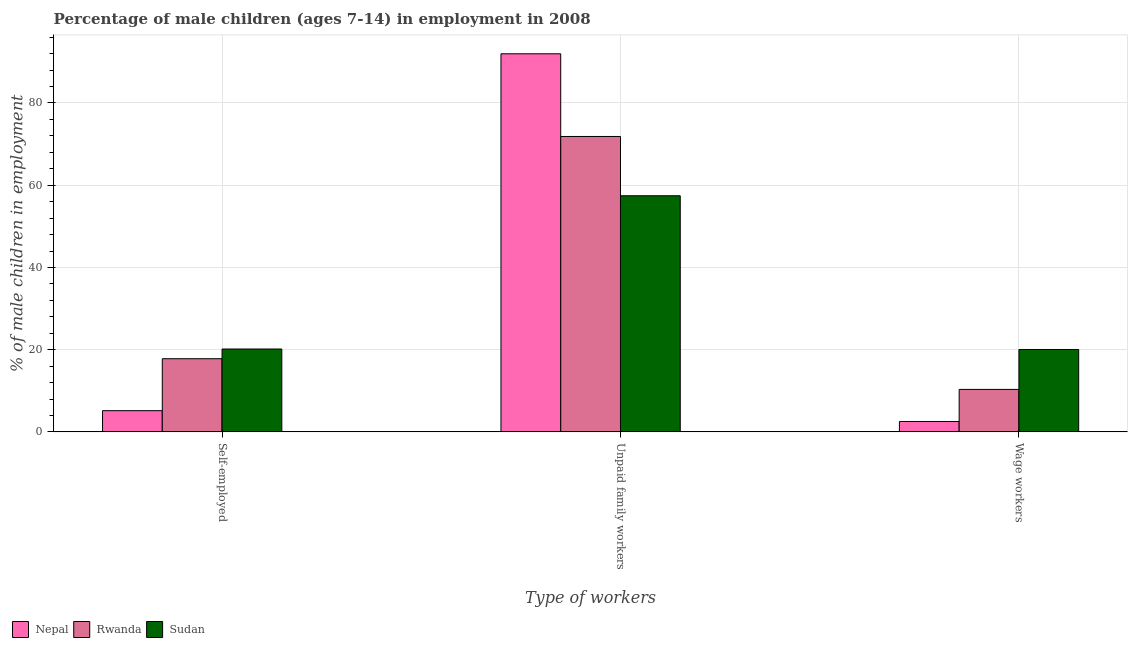How many different coloured bars are there?
Provide a short and direct response. 3. How many groups of bars are there?
Ensure brevity in your answer.  3. Are the number of bars on each tick of the X-axis equal?
Offer a very short reply. Yes. What is the label of the 1st group of bars from the left?
Offer a very short reply. Self-employed. What is the percentage of self employed children in Nepal?
Give a very brief answer. 5.17. Across all countries, what is the maximum percentage of self employed children?
Your response must be concise. 20.17. Across all countries, what is the minimum percentage of self employed children?
Ensure brevity in your answer.  5.17. In which country was the percentage of children employed as unpaid family workers maximum?
Your answer should be very brief. Nepal. In which country was the percentage of children employed as wage workers minimum?
Offer a terse response. Nepal. What is the total percentage of children employed as unpaid family workers in the graph?
Provide a short and direct response. 221.27. What is the difference between the percentage of self employed children in Sudan and that in Nepal?
Offer a terse response. 15. What is the difference between the percentage of children employed as wage workers in Nepal and the percentage of self employed children in Sudan?
Keep it short and to the point. -17.63. What is the average percentage of self employed children per country?
Your response must be concise. 14.38. What is the difference between the percentage of self employed children and percentage of children employed as wage workers in Rwanda?
Your answer should be compact. 7.47. What is the ratio of the percentage of children employed as unpaid family workers in Rwanda to that in Sudan?
Make the answer very short. 1.25. Is the percentage of children employed as wage workers in Rwanda less than that in Nepal?
Keep it short and to the point. No. Is the difference between the percentage of children employed as unpaid family workers in Nepal and Sudan greater than the difference between the percentage of self employed children in Nepal and Sudan?
Keep it short and to the point. Yes. What is the difference between the highest and the second highest percentage of children employed as wage workers?
Offer a terse response. 9.71. What is the difference between the highest and the lowest percentage of children employed as unpaid family workers?
Ensure brevity in your answer.  34.53. In how many countries, is the percentage of self employed children greater than the average percentage of self employed children taken over all countries?
Give a very brief answer. 2. Is the sum of the percentage of self employed children in Rwanda and Nepal greater than the maximum percentage of children employed as wage workers across all countries?
Give a very brief answer. Yes. What does the 2nd bar from the left in Wage workers represents?
Give a very brief answer. Rwanda. What does the 3rd bar from the right in Unpaid family workers represents?
Make the answer very short. Nepal. How many bars are there?
Your response must be concise. 9. How many countries are there in the graph?
Keep it short and to the point. 3. Does the graph contain grids?
Offer a terse response. Yes. Where does the legend appear in the graph?
Your response must be concise. Bottom left. How many legend labels are there?
Keep it short and to the point. 3. What is the title of the graph?
Your answer should be compact. Percentage of male children (ages 7-14) in employment in 2008. Does "Small states" appear as one of the legend labels in the graph?
Provide a succinct answer. No. What is the label or title of the X-axis?
Give a very brief answer. Type of workers. What is the label or title of the Y-axis?
Your answer should be very brief. % of male children in employment. What is the % of male children in employment of Nepal in Self-employed?
Your response must be concise. 5.17. What is the % of male children in employment of Rwanda in Self-employed?
Your answer should be very brief. 17.81. What is the % of male children in employment in Sudan in Self-employed?
Offer a terse response. 20.17. What is the % of male children in employment in Nepal in Unpaid family workers?
Offer a terse response. 91.97. What is the % of male children in employment in Rwanda in Unpaid family workers?
Make the answer very short. 71.86. What is the % of male children in employment in Sudan in Unpaid family workers?
Offer a very short reply. 57.44. What is the % of male children in employment in Nepal in Wage workers?
Make the answer very short. 2.54. What is the % of male children in employment of Rwanda in Wage workers?
Your answer should be compact. 10.34. What is the % of male children in employment in Sudan in Wage workers?
Provide a succinct answer. 20.05. Across all Type of workers, what is the maximum % of male children in employment of Nepal?
Ensure brevity in your answer.  91.97. Across all Type of workers, what is the maximum % of male children in employment in Rwanda?
Offer a very short reply. 71.86. Across all Type of workers, what is the maximum % of male children in employment in Sudan?
Your response must be concise. 57.44. Across all Type of workers, what is the minimum % of male children in employment in Nepal?
Give a very brief answer. 2.54. Across all Type of workers, what is the minimum % of male children in employment in Rwanda?
Ensure brevity in your answer.  10.34. Across all Type of workers, what is the minimum % of male children in employment in Sudan?
Your response must be concise. 20.05. What is the total % of male children in employment of Nepal in the graph?
Provide a succinct answer. 99.68. What is the total % of male children in employment of Rwanda in the graph?
Provide a succinct answer. 100.01. What is the total % of male children in employment of Sudan in the graph?
Give a very brief answer. 97.66. What is the difference between the % of male children in employment of Nepal in Self-employed and that in Unpaid family workers?
Offer a terse response. -86.8. What is the difference between the % of male children in employment in Rwanda in Self-employed and that in Unpaid family workers?
Give a very brief answer. -54.05. What is the difference between the % of male children in employment in Sudan in Self-employed and that in Unpaid family workers?
Your response must be concise. -37.27. What is the difference between the % of male children in employment in Nepal in Self-employed and that in Wage workers?
Provide a short and direct response. 2.63. What is the difference between the % of male children in employment of Rwanda in Self-employed and that in Wage workers?
Make the answer very short. 7.47. What is the difference between the % of male children in employment of Sudan in Self-employed and that in Wage workers?
Your response must be concise. 0.12. What is the difference between the % of male children in employment in Nepal in Unpaid family workers and that in Wage workers?
Offer a terse response. 89.43. What is the difference between the % of male children in employment in Rwanda in Unpaid family workers and that in Wage workers?
Your answer should be compact. 61.52. What is the difference between the % of male children in employment in Sudan in Unpaid family workers and that in Wage workers?
Offer a terse response. 37.39. What is the difference between the % of male children in employment in Nepal in Self-employed and the % of male children in employment in Rwanda in Unpaid family workers?
Offer a terse response. -66.69. What is the difference between the % of male children in employment of Nepal in Self-employed and the % of male children in employment of Sudan in Unpaid family workers?
Make the answer very short. -52.27. What is the difference between the % of male children in employment in Rwanda in Self-employed and the % of male children in employment in Sudan in Unpaid family workers?
Your answer should be compact. -39.63. What is the difference between the % of male children in employment in Nepal in Self-employed and the % of male children in employment in Rwanda in Wage workers?
Offer a very short reply. -5.17. What is the difference between the % of male children in employment in Nepal in Self-employed and the % of male children in employment in Sudan in Wage workers?
Your answer should be compact. -14.88. What is the difference between the % of male children in employment of Rwanda in Self-employed and the % of male children in employment of Sudan in Wage workers?
Provide a succinct answer. -2.24. What is the difference between the % of male children in employment in Nepal in Unpaid family workers and the % of male children in employment in Rwanda in Wage workers?
Provide a succinct answer. 81.63. What is the difference between the % of male children in employment in Nepal in Unpaid family workers and the % of male children in employment in Sudan in Wage workers?
Offer a terse response. 71.92. What is the difference between the % of male children in employment of Rwanda in Unpaid family workers and the % of male children in employment of Sudan in Wage workers?
Keep it short and to the point. 51.81. What is the average % of male children in employment of Nepal per Type of workers?
Provide a short and direct response. 33.23. What is the average % of male children in employment of Rwanda per Type of workers?
Your response must be concise. 33.34. What is the average % of male children in employment of Sudan per Type of workers?
Your answer should be compact. 32.55. What is the difference between the % of male children in employment in Nepal and % of male children in employment in Rwanda in Self-employed?
Ensure brevity in your answer.  -12.64. What is the difference between the % of male children in employment of Nepal and % of male children in employment of Sudan in Self-employed?
Ensure brevity in your answer.  -15. What is the difference between the % of male children in employment in Rwanda and % of male children in employment in Sudan in Self-employed?
Ensure brevity in your answer.  -2.36. What is the difference between the % of male children in employment of Nepal and % of male children in employment of Rwanda in Unpaid family workers?
Provide a succinct answer. 20.11. What is the difference between the % of male children in employment in Nepal and % of male children in employment in Sudan in Unpaid family workers?
Keep it short and to the point. 34.53. What is the difference between the % of male children in employment of Rwanda and % of male children in employment of Sudan in Unpaid family workers?
Your response must be concise. 14.42. What is the difference between the % of male children in employment of Nepal and % of male children in employment of Sudan in Wage workers?
Your response must be concise. -17.51. What is the difference between the % of male children in employment in Rwanda and % of male children in employment in Sudan in Wage workers?
Ensure brevity in your answer.  -9.71. What is the ratio of the % of male children in employment in Nepal in Self-employed to that in Unpaid family workers?
Provide a short and direct response. 0.06. What is the ratio of the % of male children in employment of Rwanda in Self-employed to that in Unpaid family workers?
Ensure brevity in your answer.  0.25. What is the ratio of the % of male children in employment in Sudan in Self-employed to that in Unpaid family workers?
Make the answer very short. 0.35. What is the ratio of the % of male children in employment of Nepal in Self-employed to that in Wage workers?
Keep it short and to the point. 2.04. What is the ratio of the % of male children in employment in Rwanda in Self-employed to that in Wage workers?
Provide a short and direct response. 1.72. What is the ratio of the % of male children in employment of Sudan in Self-employed to that in Wage workers?
Ensure brevity in your answer.  1.01. What is the ratio of the % of male children in employment in Nepal in Unpaid family workers to that in Wage workers?
Offer a very short reply. 36.21. What is the ratio of the % of male children in employment of Rwanda in Unpaid family workers to that in Wage workers?
Keep it short and to the point. 6.95. What is the ratio of the % of male children in employment in Sudan in Unpaid family workers to that in Wage workers?
Your response must be concise. 2.86. What is the difference between the highest and the second highest % of male children in employment in Nepal?
Provide a succinct answer. 86.8. What is the difference between the highest and the second highest % of male children in employment of Rwanda?
Keep it short and to the point. 54.05. What is the difference between the highest and the second highest % of male children in employment of Sudan?
Your answer should be very brief. 37.27. What is the difference between the highest and the lowest % of male children in employment of Nepal?
Your response must be concise. 89.43. What is the difference between the highest and the lowest % of male children in employment of Rwanda?
Provide a short and direct response. 61.52. What is the difference between the highest and the lowest % of male children in employment of Sudan?
Provide a succinct answer. 37.39. 